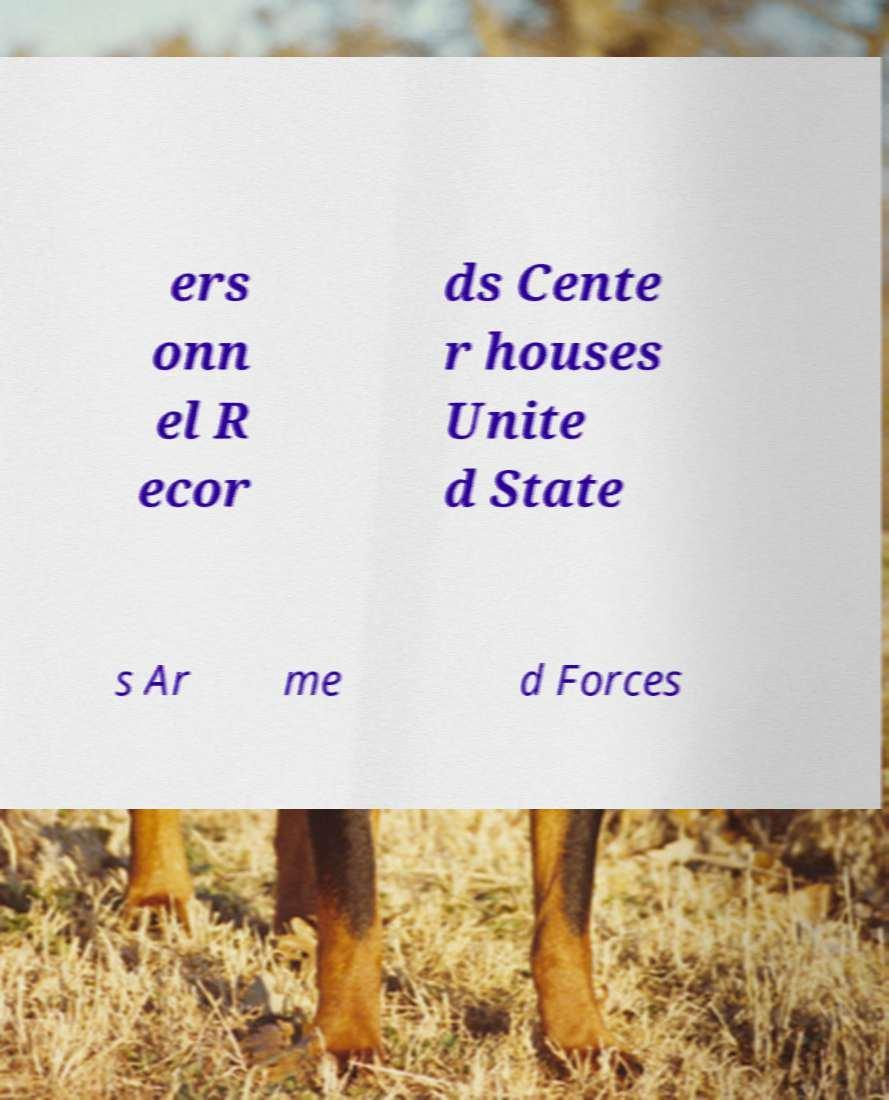There's text embedded in this image that I need extracted. Can you transcribe it verbatim? ers onn el R ecor ds Cente r houses Unite d State s Ar me d Forces 